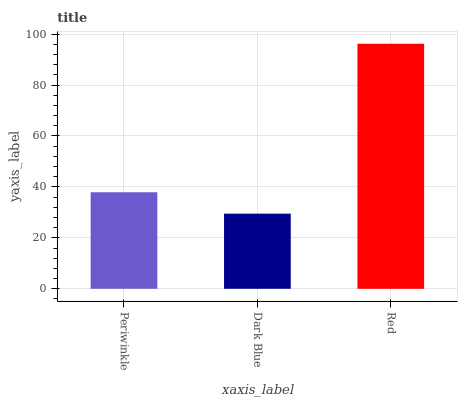Is Dark Blue the minimum?
Answer yes or no. Yes. Is Red the maximum?
Answer yes or no. Yes. Is Red the minimum?
Answer yes or no. No. Is Dark Blue the maximum?
Answer yes or no. No. Is Red greater than Dark Blue?
Answer yes or no. Yes. Is Dark Blue less than Red?
Answer yes or no. Yes. Is Dark Blue greater than Red?
Answer yes or no. No. Is Red less than Dark Blue?
Answer yes or no. No. Is Periwinkle the high median?
Answer yes or no. Yes. Is Periwinkle the low median?
Answer yes or no. Yes. Is Dark Blue the high median?
Answer yes or no. No. Is Red the low median?
Answer yes or no. No. 